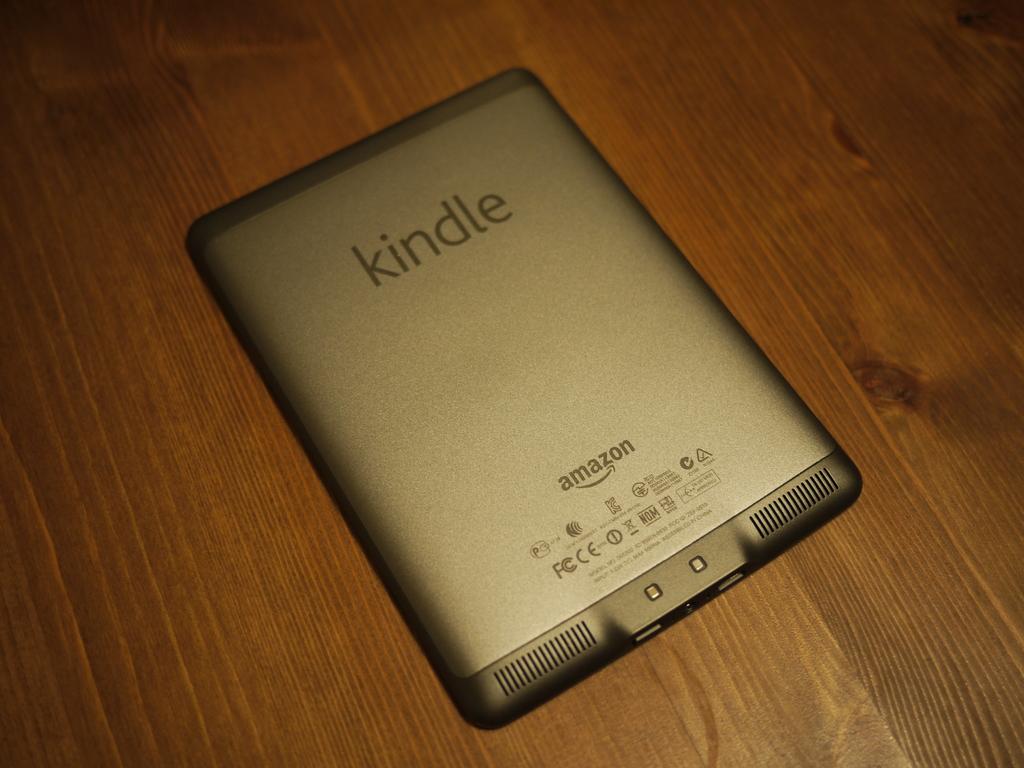What type of tablet is this?
Provide a short and direct response. Kindle. 